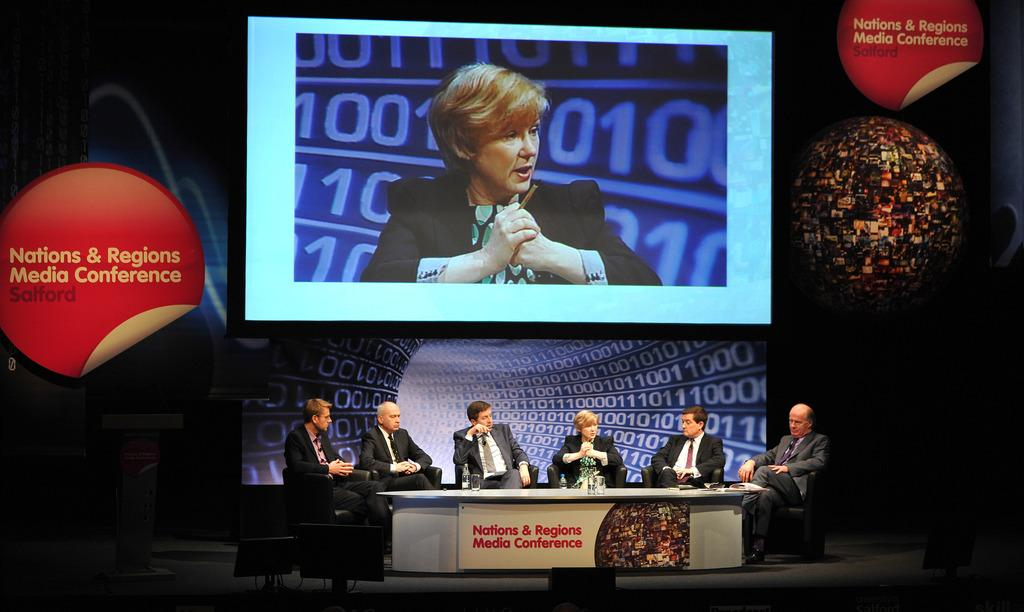<image>
Write a terse but informative summary of the picture. Six professionals take part in a media conference that's underway in Salford. 